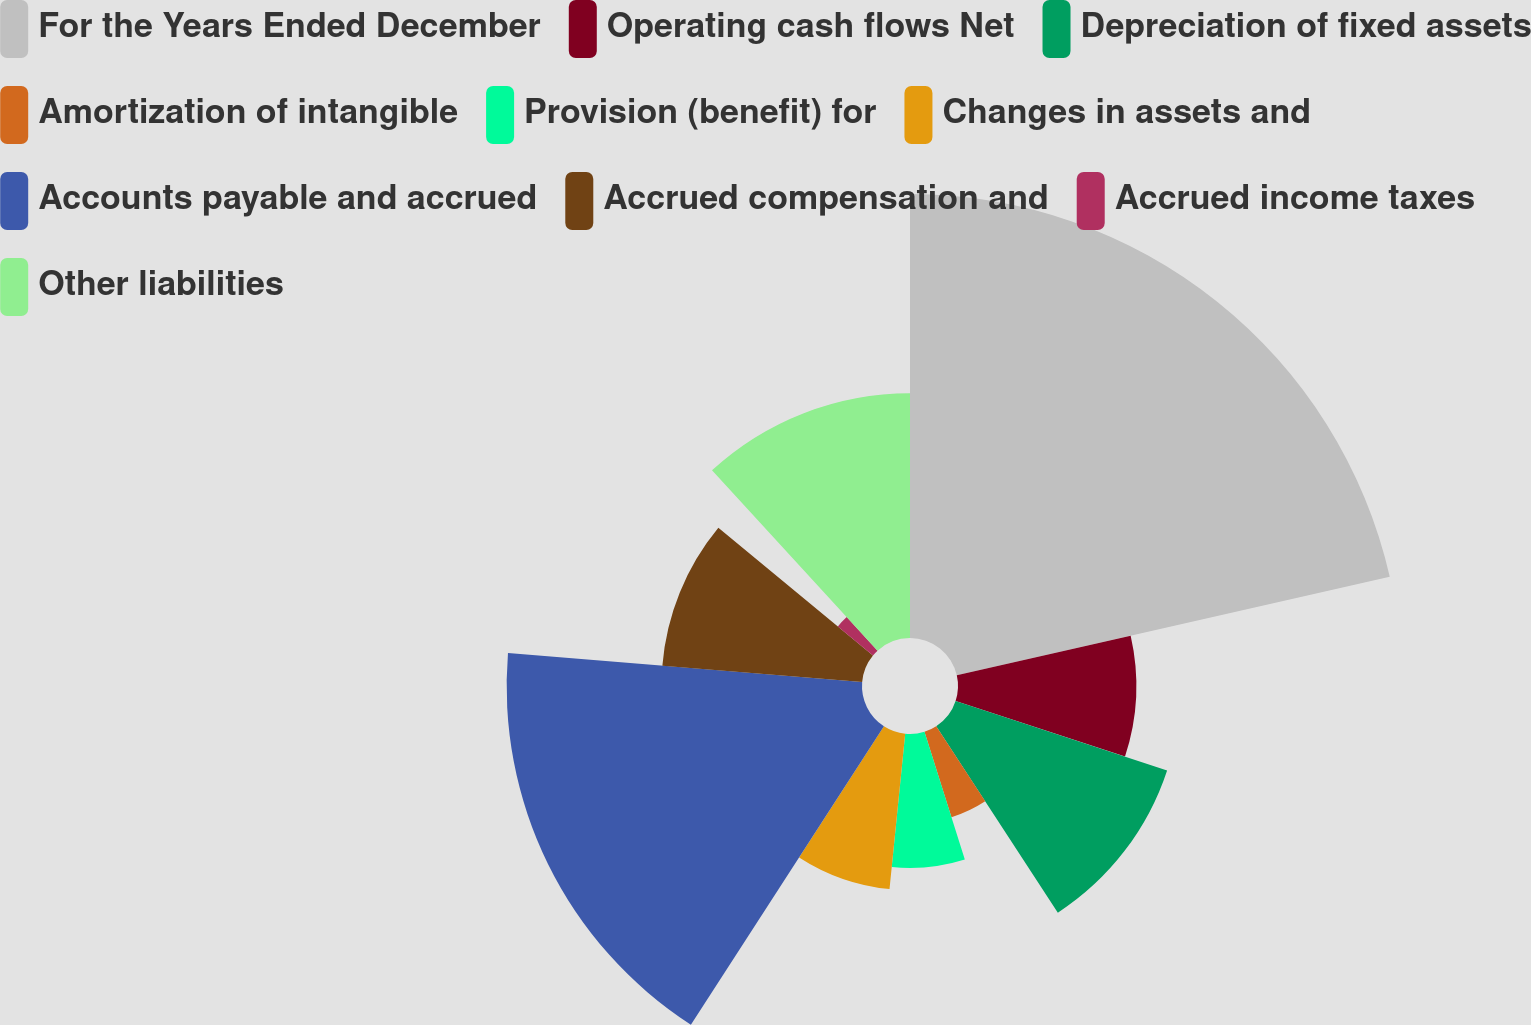Convert chart. <chart><loc_0><loc_0><loc_500><loc_500><pie_chart><fcel>For the Years Ended December<fcel>Operating cash flows Net<fcel>Depreciation of fixed assets<fcel>Amortization of intangible<fcel>Provision (benefit) for<fcel>Changes in assets and<fcel>Accounts payable and accrued<fcel>Accrued compensation and<fcel>Accrued income taxes<fcel>Other liabilities<nl><fcel>21.44%<fcel>8.61%<fcel>10.75%<fcel>4.33%<fcel>6.47%<fcel>7.54%<fcel>17.16%<fcel>9.68%<fcel>2.2%<fcel>11.82%<nl></chart> 